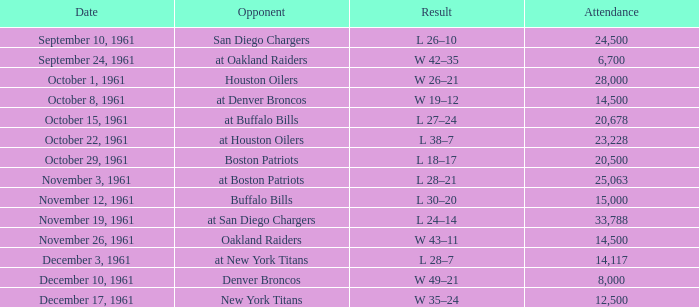What is the low attendance rate against buffalo bills? 15000.0. 